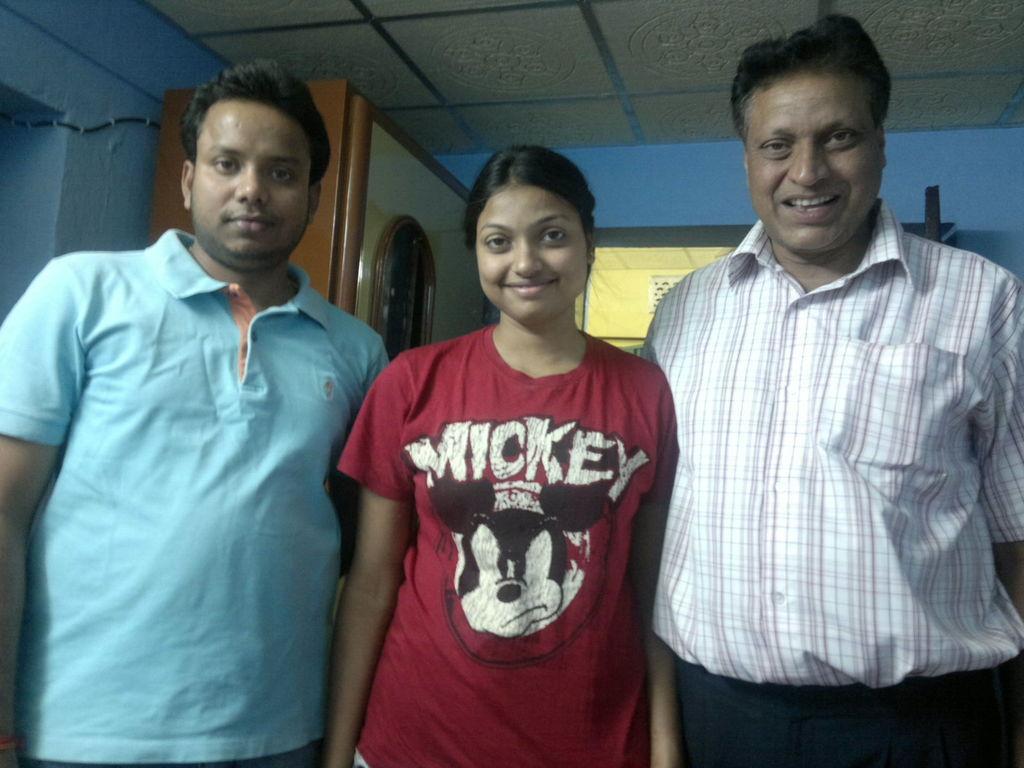In one or two sentences, can you explain what this image depicts? In the picture there are three people, two men and a woman standing and posing for the photo in a room. Behind them there is a cabinet and beside that there is a blue color wall. 